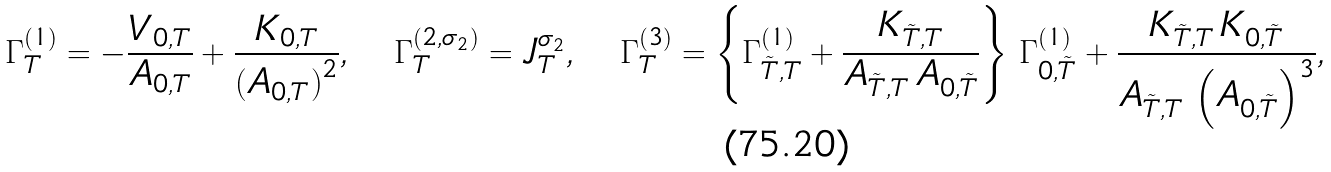<formula> <loc_0><loc_0><loc_500><loc_500>\Gamma _ { T } ^ { \left ( 1 \right ) } = - \frac { V _ { 0 , T } } { A _ { 0 , T } } + \frac { K _ { 0 , T } } { \left ( A _ { 0 , T } \right ) ^ { 2 } } , \quad \Gamma _ { T } ^ { \left ( 2 , \sigma _ { 2 } \right ) } = J _ { T } ^ { \sigma _ { 2 } } , \quad \Gamma _ { T } ^ { \left ( 3 \right ) } = \left \{ \Gamma _ { \tilde { T } , T } ^ { ( 1 ) } + \frac { K _ { \tilde { T } , T } } { A _ { \tilde { T } , T } \, A _ { 0 , \tilde { T } } } \right \} \, \Gamma _ { 0 , \tilde { T } } ^ { ( 1 ) } + \frac { K _ { \tilde { T } , T } \, K _ { 0 , \tilde { T } } } { A _ { \tilde { T } , T } \, \left ( A _ { 0 , \tilde { T } } \right ) ^ { 3 } } ,</formula> 